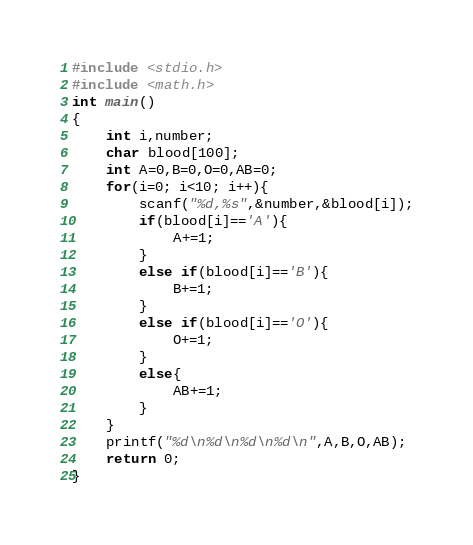<code> <loc_0><loc_0><loc_500><loc_500><_C_>#include <stdio.h>
#include <math.h>
int main()
{
	int i,number;
	char blood[100];
	int A=0,B=0,O=0,AB=0;
	for(i=0; i<10; i++){
		scanf("%d,%s",&number,&blood[i]);
		if(blood[i]=='A'){
			A+=1;
		}
		else if(blood[i]=='B'){
			B+=1;
		}
		else if(blood[i]=='O'){
			O+=1;
		}
		else{
			AB+=1;
		}
	}
	printf("%d\n%d\n%d\n%d\n",A,B,O,AB);
	return 0;
}</code> 